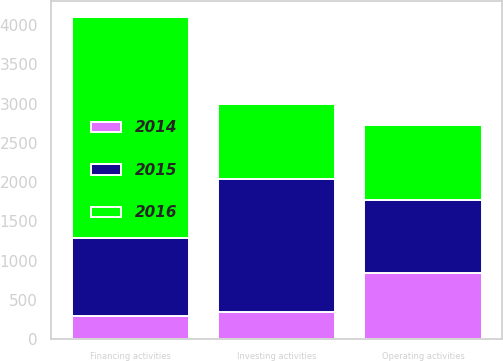<chart> <loc_0><loc_0><loc_500><loc_500><stacked_bar_chart><ecel><fcel>Operating activities<fcel>Investing activities<fcel>Financing activities<nl><fcel>2016<fcel>964<fcel>946.5<fcel>2805<nl><fcel>2015<fcel>929<fcel>1698<fcel>996<nl><fcel>2014<fcel>840<fcel>348<fcel>298<nl></chart> 